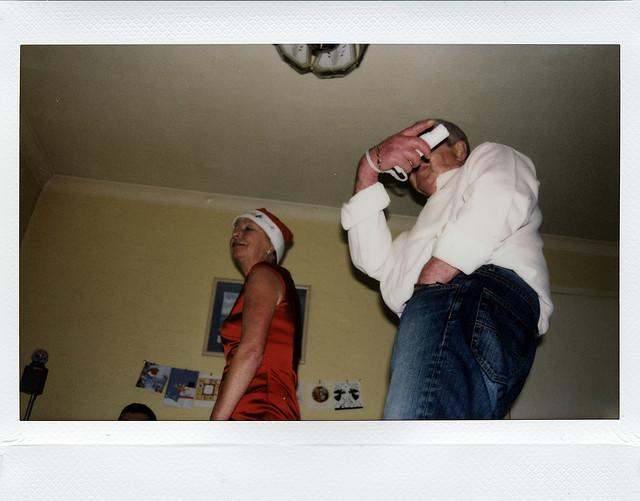What is the woman wearing on her head? Please explain your reasoning. headband. The woman is wearing a headband. 